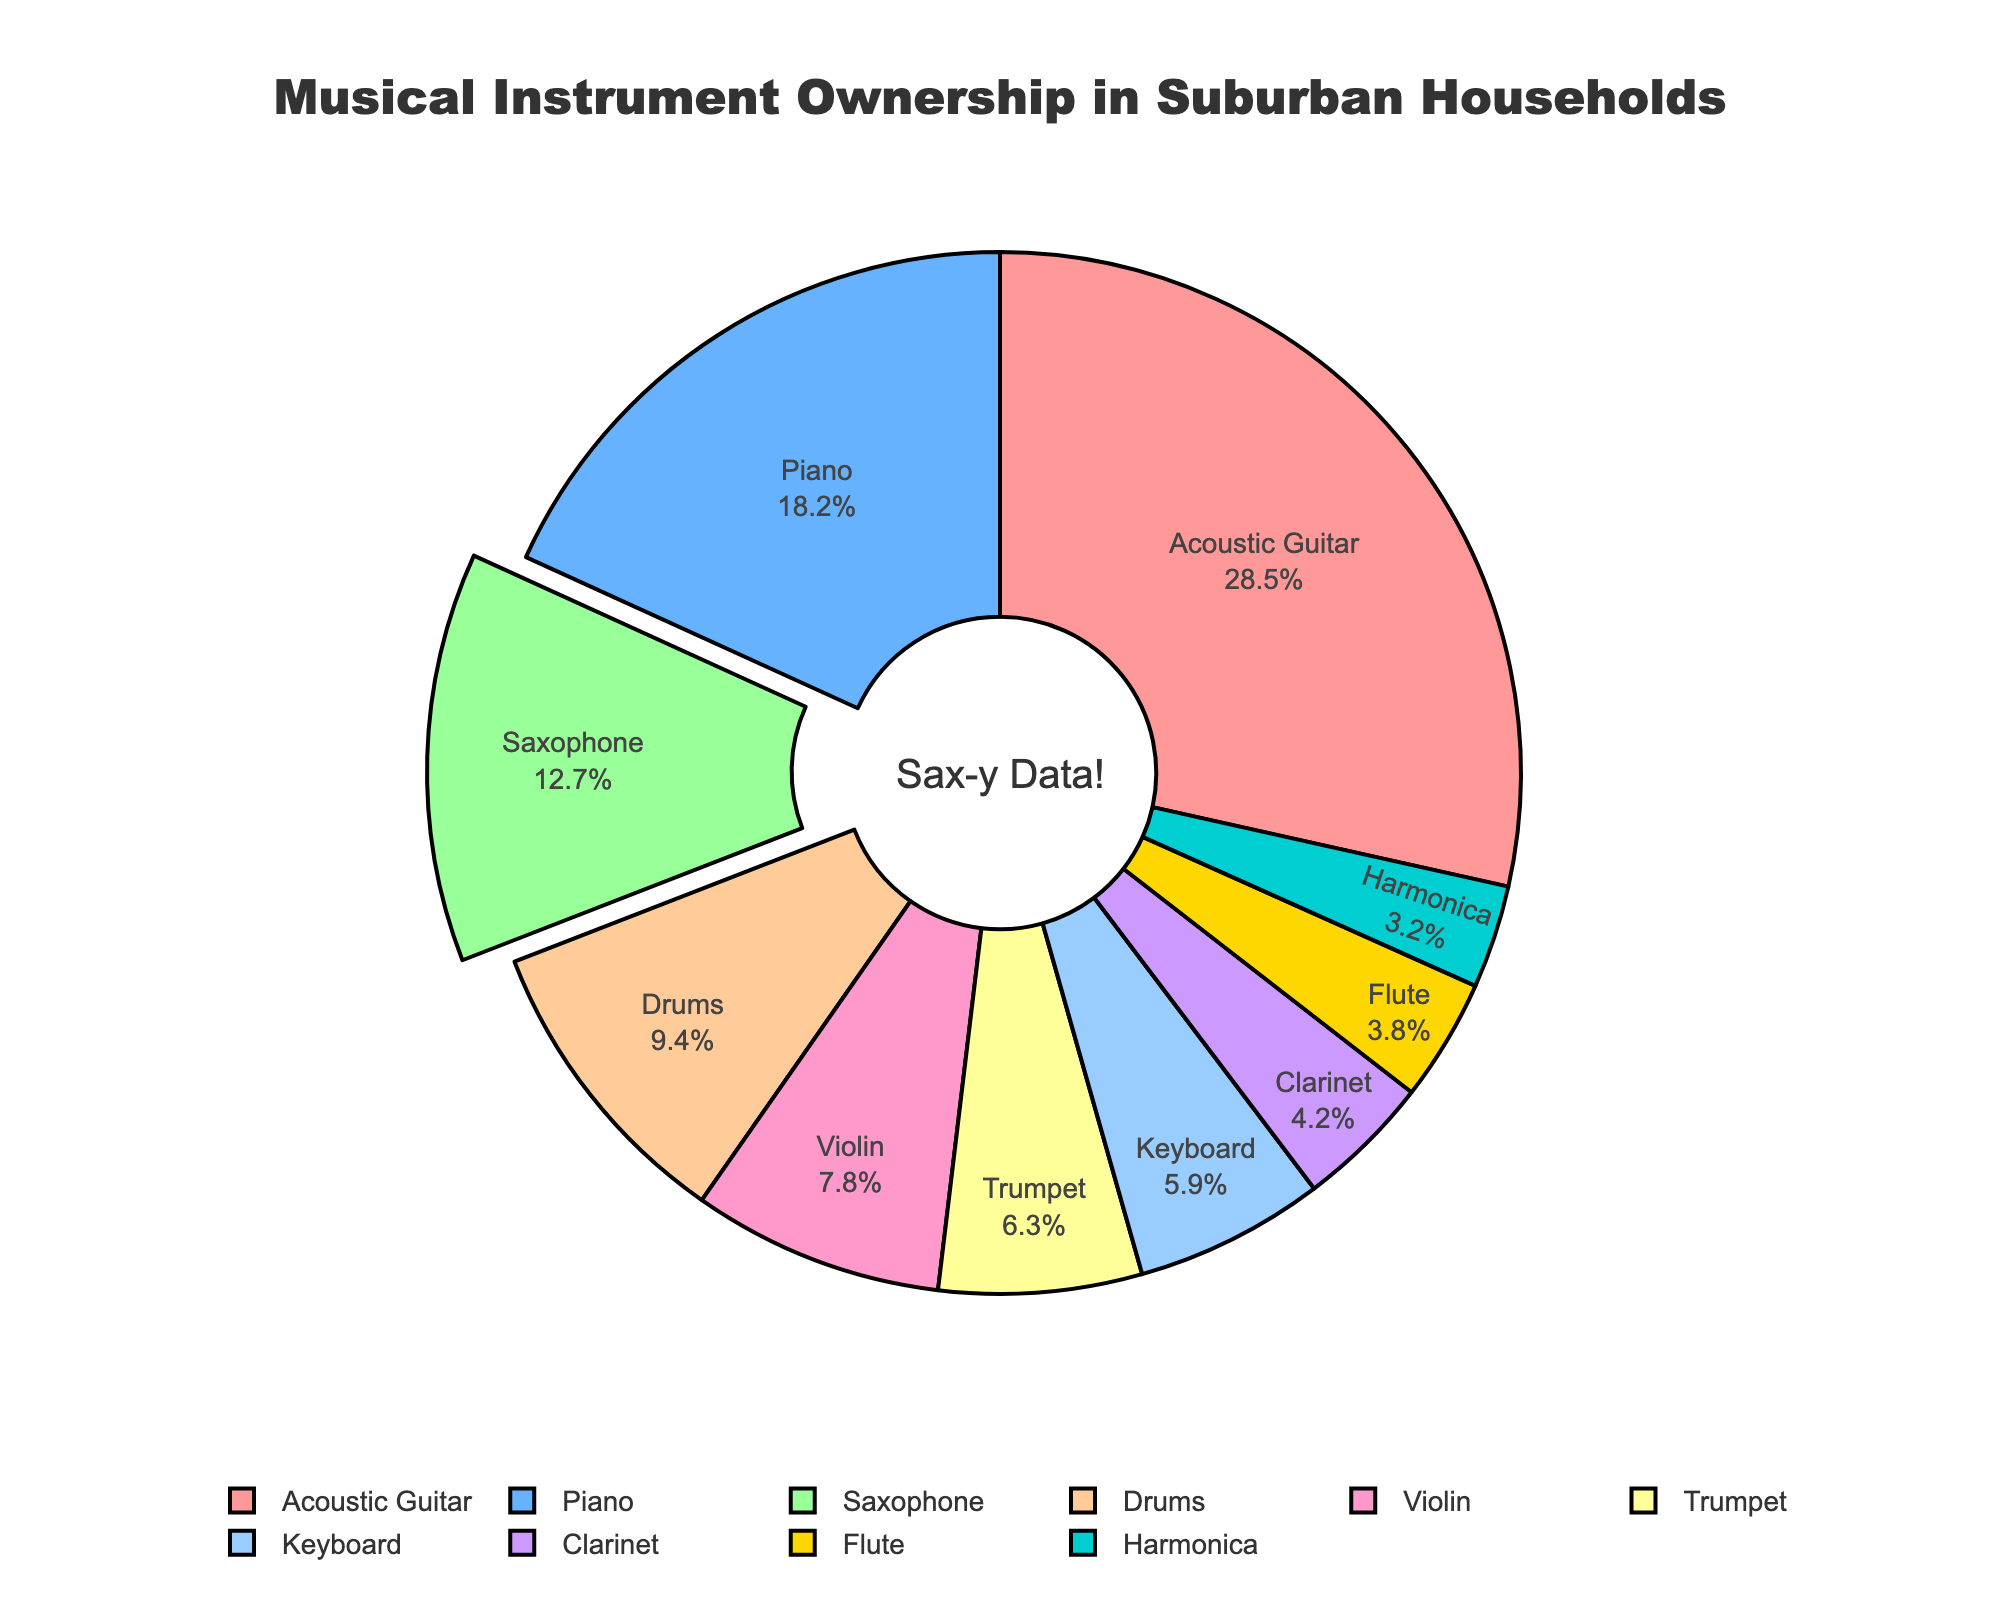What percentage of households own an Acoustic Guitar? This question is asking for a specific percentage value from the pie chart. Look for the label "Acoustic Guitar" and read the associated percentage.
Answer: 28.5% Which instrument has the smallest percentage of ownership? To determine the smallest percentage, scan through all the percentage values in the pie chart and identify the smallest one.
Answer: Harmonica Is the ownership of Saxophones greater than Keyboards? Compare the percentage of ownership for Saxophones and Keyboards to see which is higher. Saxophones have 12.7%, and Keyboards have 5.9%.
Answer: Yes What is the combined percentage of Piano, Drums, and Violin ownership? Add the percentages of households owning these instruments: Piano (18.2%) + Drums (9.4%) + Violin (7.8%). The sum is 18.2 + 9.4 + 7.8.
Answer: 35.4% How many instruments have a greater ownership percentage than the Saxophone? Find the percentage of Saxophone ownership (12.7%), then count how many instruments have a percentage higher than this. Acoustic Guitar and Piano have higher percentages.
Answer: Two Which instrument has a pulled-out segment in the pie chart? This question refers to the visual attribute of the pie chart where one segment is visually separated or emphasized. The pull-out segment is identified by observing the pie chart.
Answer: Saxophone Is the total percentage of households owning either a Trumpet or a Clarinet less than 15%? Add percentages of Trumpet (6.3%) and Clarinet (4.2%) and compare to 15%. 6.3 + 4.2 is 10.5, which is less than 15%.
Answer: Yes What is the difference in percentage ownership between the instrument with the highest and lowest ownership? Find the highest percentage (Acoustic Guitar, 28.5%) and the lowest percentage (Harmonica, 3.2%), then subtract the lowest from the highest. 28.5 - 3.2 is 25.3.
Answer: 25.3% Which instruments are owned by less than 5% of households? Look for instruments with percentage values below 5% and list them. Clarinet (4.2%), Flute (3.8%), and Harmonica (3.2%) fall under this category.
Answer: Clarinet, Flute, Harmonica 